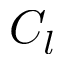<formula> <loc_0><loc_0><loc_500><loc_500>C _ { l }</formula> 